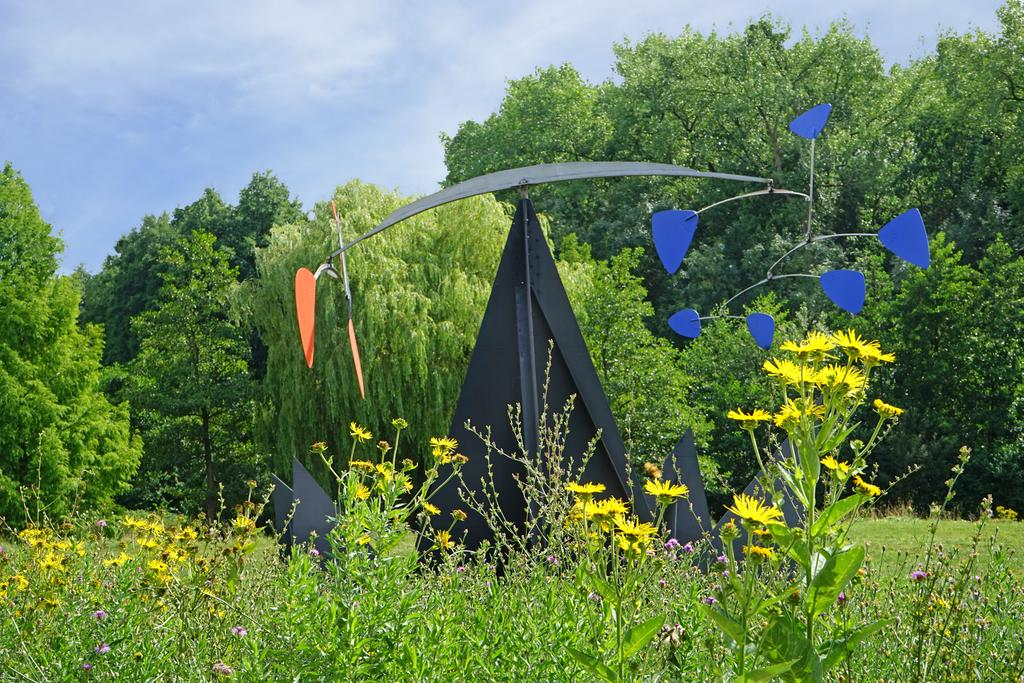What is the color of the object in the image? The object in the image is black. Where is the black object located? The black object is placed on the grass. What can be seen around the black object? There are flowers around the black object. What type of vegetation is present in the image? There are plants and trees in the image. What time of day is it in the image, considering the presence of the hall and night? There is no hall or night mentioned in the image, as it features a black object placed on the grass with flowers and trees surrounding it. 